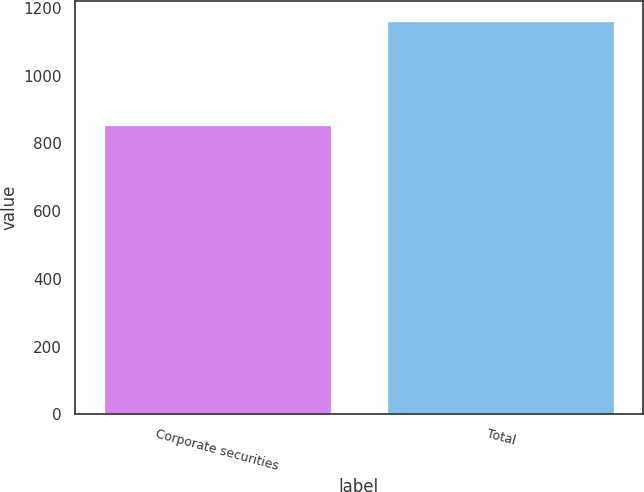Convert chart to OTSL. <chart><loc_0><loc_0><loc_500><loc_500><bar_chart><fcel>Corporate securities<fcel>Total<nl><fcel>855<fcel>1162<nl></chart> 